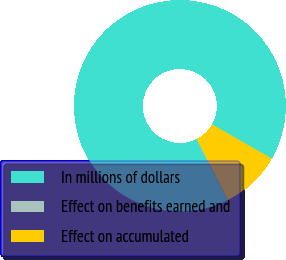Convert chart to OTSL. <chart><loc_0><loc_0><loc_500><loc_500><pie_chart><fcel>In millions of dollars<fcel>Effect on benefits earned and<fcel>Effect on accumulated<nl><fcel>90.67%<fcel>0.14%<fcel>9.19%<nl></chart> 